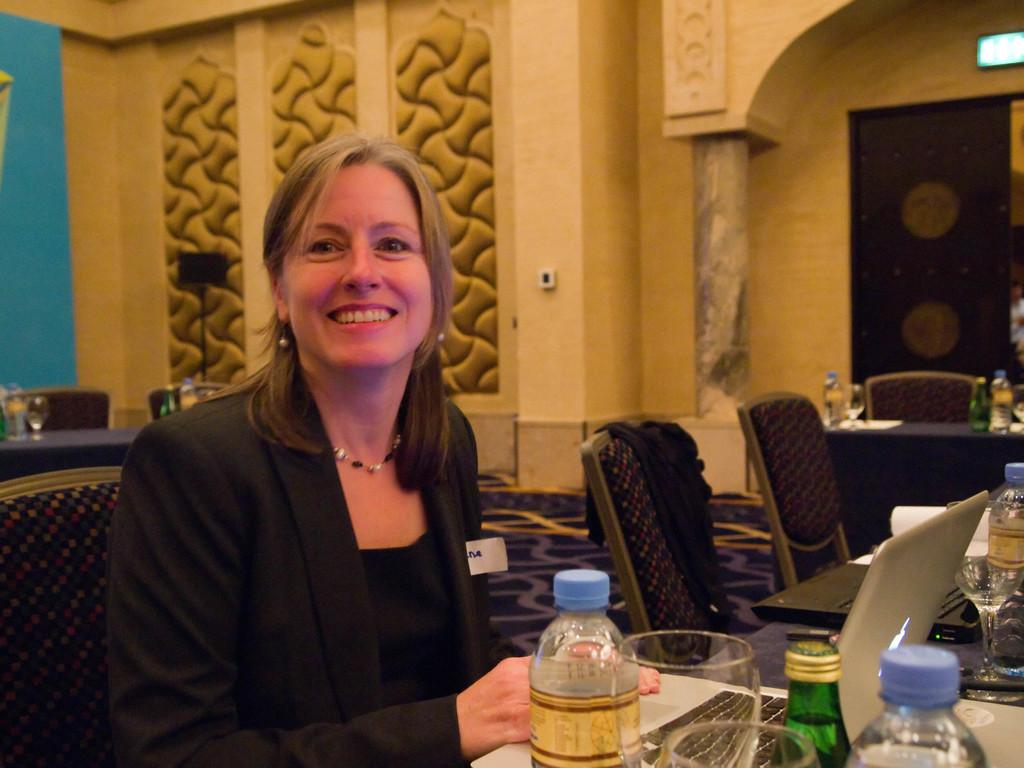Who is present in the image? There is a woman in the image. What is the woman doing in the image? The woman is sitting in a chair and at a table. What object is in front of the woman on the table? There is a laptop in front of the woman. What other items can be seen on the table? There are bottles and glasses on the table. What type of pet can be seen playing with the laptop in the image? There is no pet present in the image, and the laptop is not being played with. 